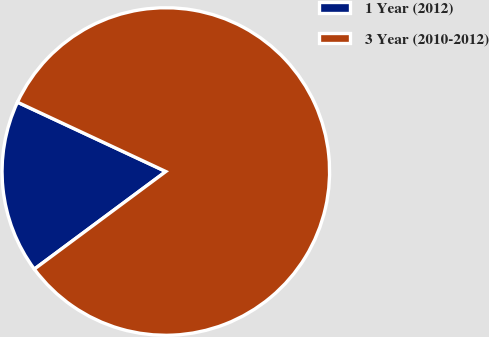<chart> <loc_0><loc_0><loc_500><loc_500><pie_chart><fcel>1 Year (2012)<fcel>3 Year (2010-2012)<nl><fcel>17.12%<fcel>82.88%<nl></chart> 